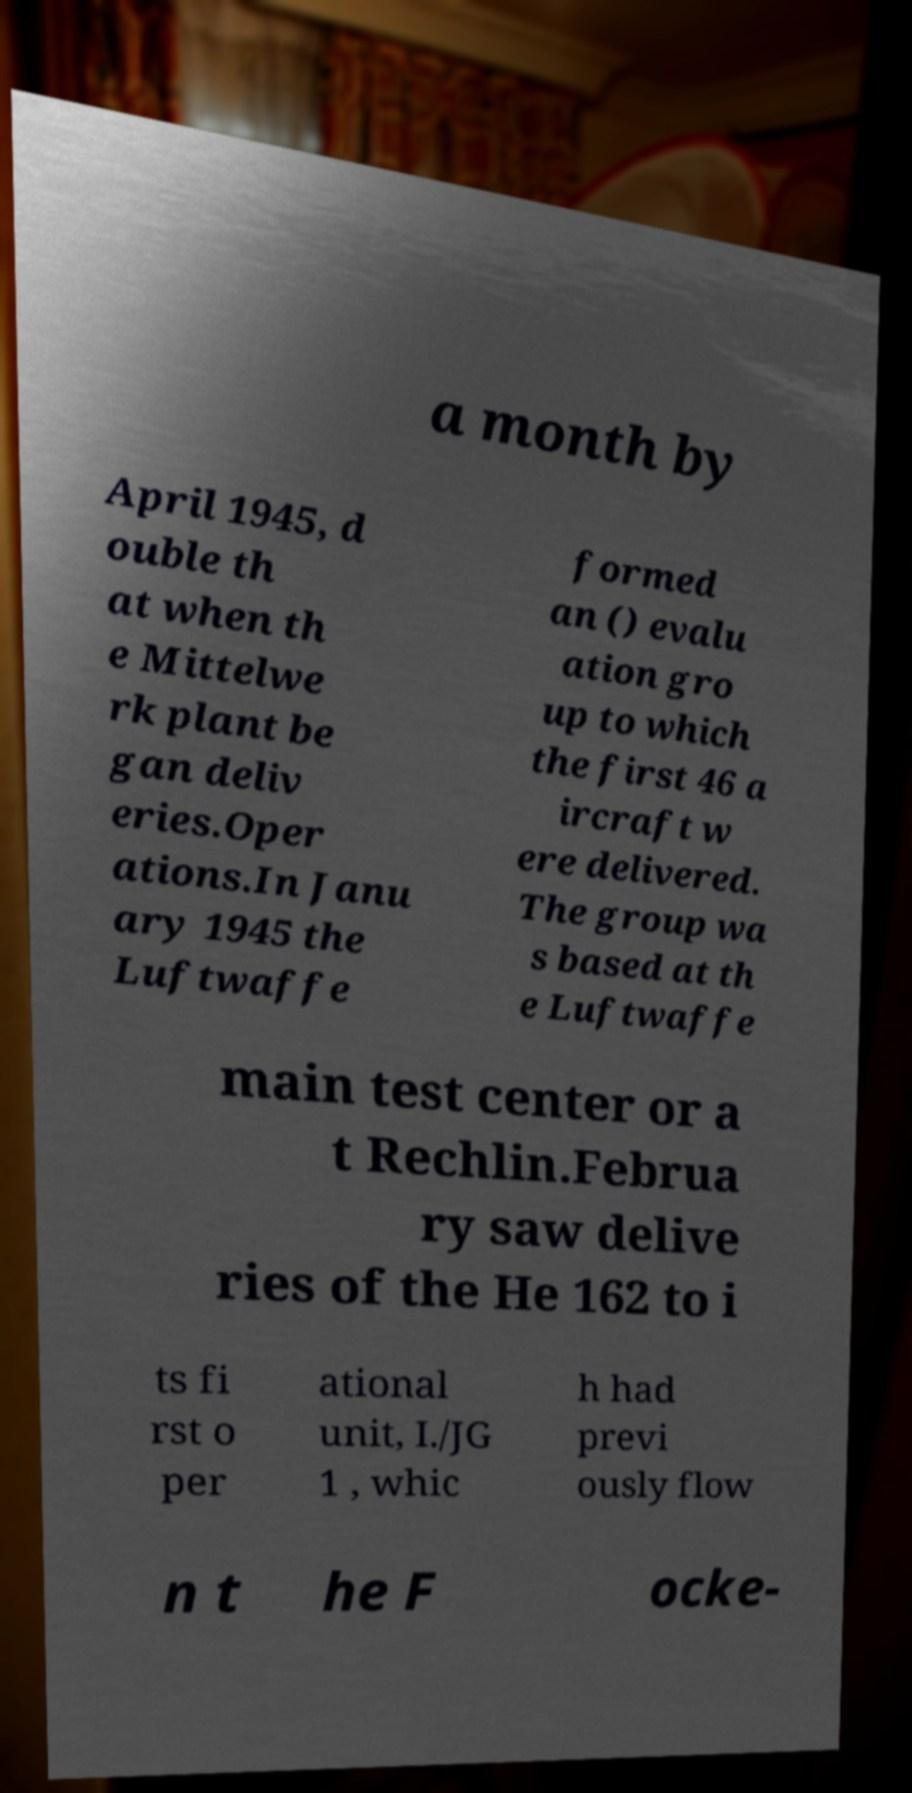What messages or text are displayed in this image? I need them in a readable, typed format. a month by April 1945, d ouble th at when th e Mittelwe rk plant be gan deliv eries.Oper ations.In Janu ary 1945 the Luftwaffe formed an () evalu ation gro up to which the first 46 a ircraft w ere delivered. The group wa s based at th e Luftwaffe main test center or a t Rechlin.Februa ry saw delive ries of the He 162 to i ts fi rst o per ational unit, I./JG 1 , whic h had previ ously flow n t he F ocke- 